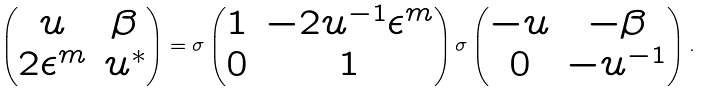<formula> <loc_0><loc_0><loc_500><loc_500>\begin{pmatrix} u & \beta \\ 2 \epsilon ^ { m } & u ^ { \ast } \end{pmatrix} = \sigma \begin{pmatrix} 1 & - 2 u ^ { - 1 } \epsilon ^ { m } \\ 0 & 1 \end{pmatrix} \sigma \begin{pmatrix} - u & - \beta \\ 0 & - u ^ { - 1 } \end{pmatrix} .</formula> 